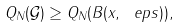<formula> <loc_0><loc_0><loc_500><loc_500>Q _ { N } ( \mathcal { G } ) \geq Q _ { N } ( B ( x , \ e p s ) ) ,</formula> 